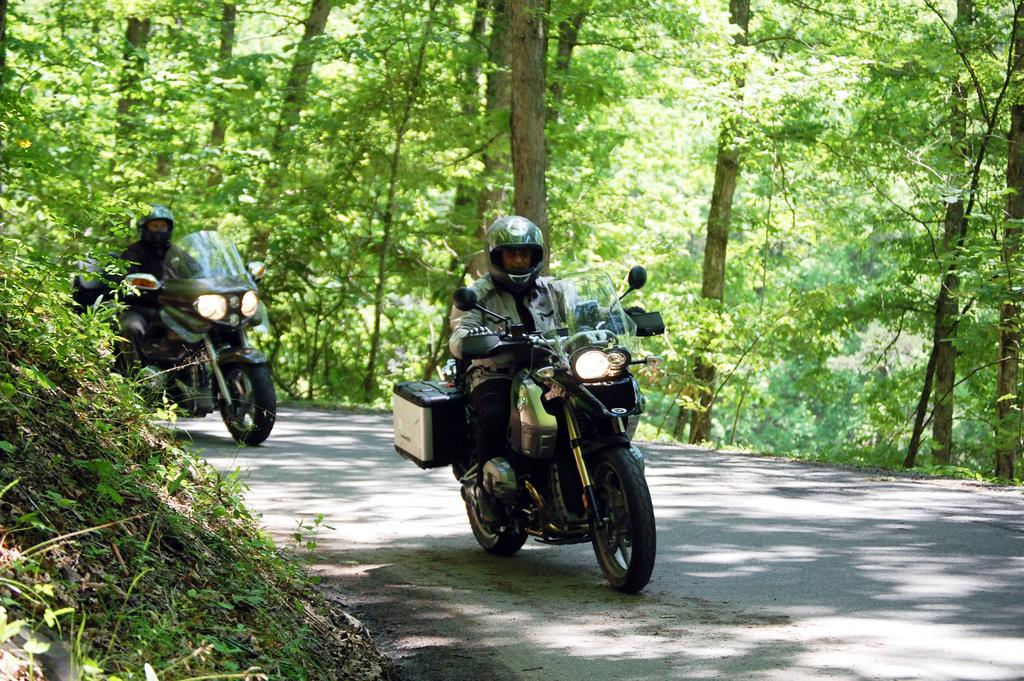How many people are in the image? There are two persons in the image. What are the persons wearing on their heads? Both persons are wearing helmets. What type of clothing are the persons wearing on their upper bodies? Both persons are wearing jackets. What are the persons doing in the image? They are riding motorbikes. Where are the persons located? They are on a road. What can be seen in the background of the image? There are planets and trees visible in the background. What type of iron can be seen in the image? There is no iron present in the image. How many thumbs can be seen on the persons in the image? It is not possible to determine the number of thumbs visible in the image, as the persons are wearing gloves or jackets that cover their hands. 